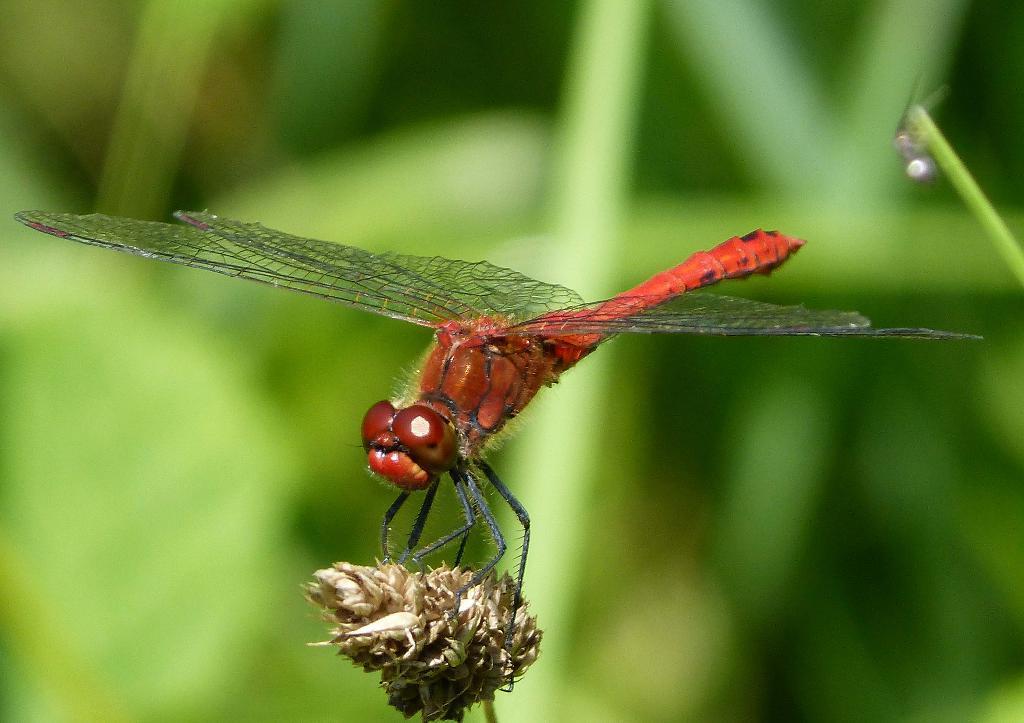Please provide a concise description of this image. In this image I can see the dragonfly which is in red and black color. It is on the flower. In the back I can see the plant but it is blurry. 